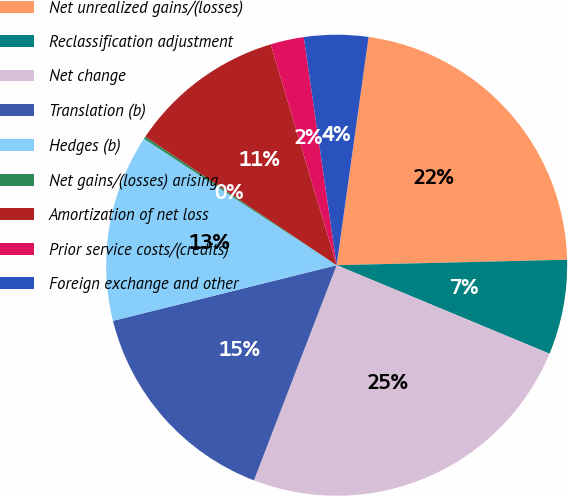Convert chart. <chart><loc_0><loc_0><loc_500><loc_500><pie_chart><fcel>Net unrealized gains/(losses)<fcel>Reclassification adjustment<fcel>Net change<fcel>Translation (b)<fcel>Hedges (b)<fcel>Net gains/(losses) arising<fcel>Amortization of net loss<fcel>Prior service costs/(credits)<fcel>Foreign exchange and other<nl><fcel>22.41%<fcel>6.65%<fcel>24.57%<fcel>15.28%<fcel>13.12%<fcel>0.18%<fcel>10.96%<fcel>2.34%<fcel>4.49%<nl></chart> 